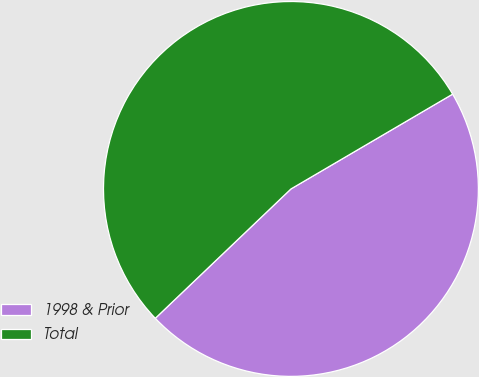Convert chart. <chart><loc_0><loc_0><loc_500><loc_500><pie_chart><fcel>1998 & Prior<fcel>Total<nl><fcel>46.32%<fcel>53.68%<nl></chart> 